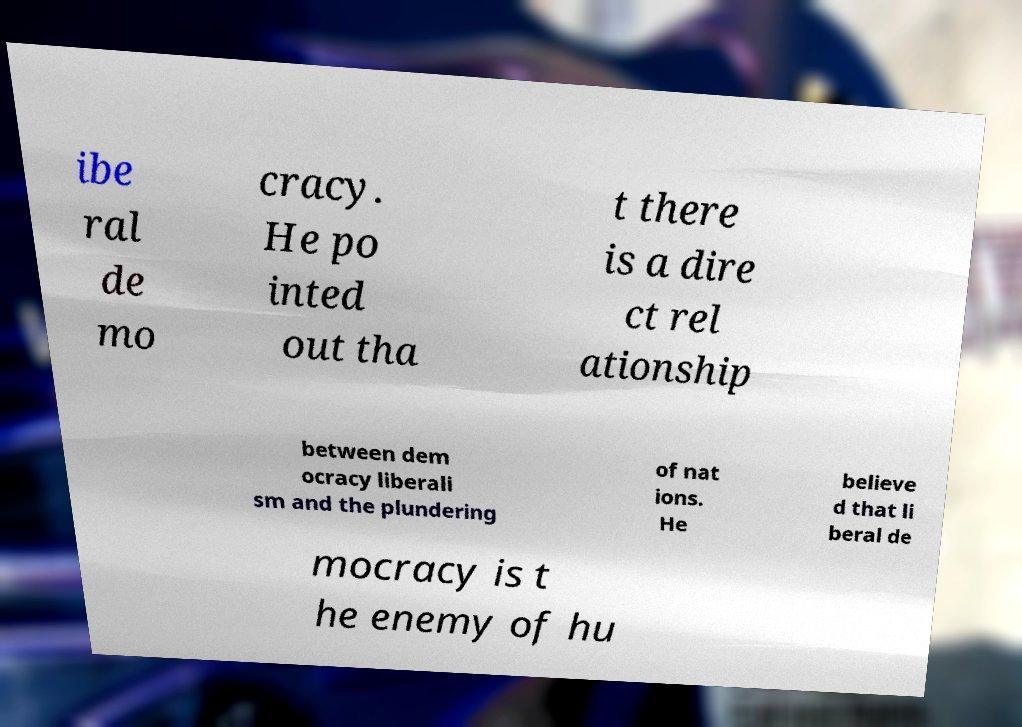Please read and relay the text visible in this image. What does it say? ibe ral de mo cracy. He po inted out tha t there is a dire ct rel ationship between dem ocracy liberali sm and the plundering of nat ions. He believe d that li beral de mocracy is t he enemy of hu 